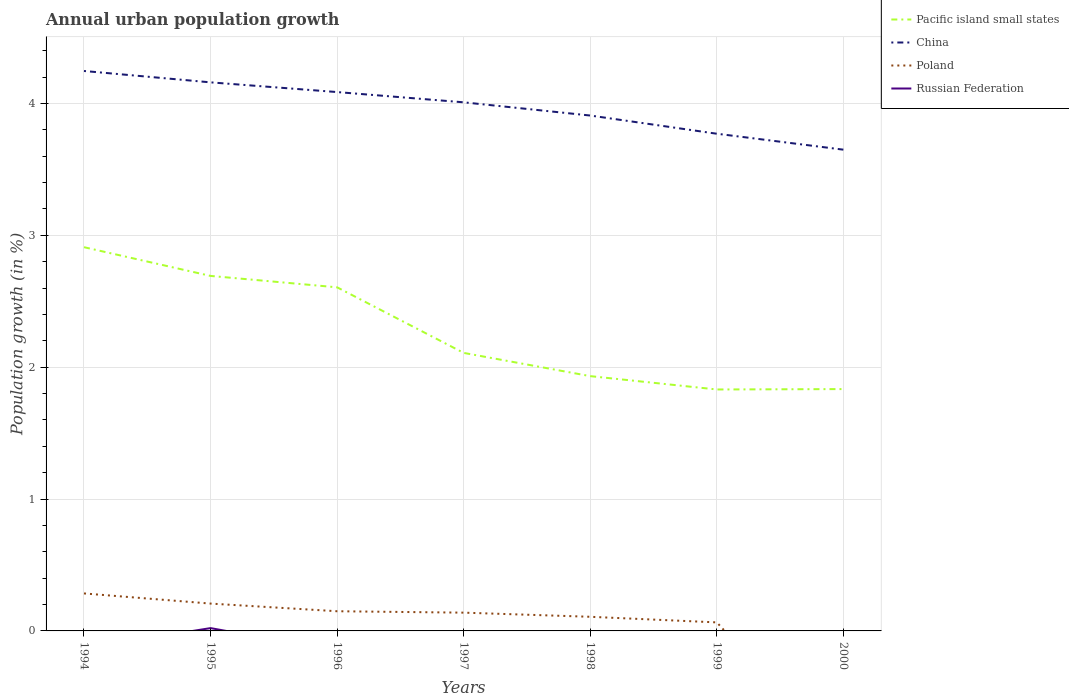How many different coloured lines are there?
Your answer should be very brief. 4. Does the line corresponding to China intersect with the line corresponding to Russian Federation?
Your answer should be compact. No. Across all years, what is the maximum percentage of urban population growth in China?
Provide a succinct answer. 3.65. What is the total percentage of urban population growth in Pacific island small states in the graph?
Offer a terse response. 0.3. What is the difference between the highest and the second highest percentage of urban population growth in China?
Give a very brief answer. 0.6. What is the difference between the highest and the lowest percentage of urban population growth in China?
Your answer should be compact. 4. Is the percentage of urban population growth in Poland strictly greater than the percentage of urban population growth in Pacific island small states over the years?
Ensure brevity in your answer.  Yes. How many lines are there?
Give a very brief answer. 4. Are the values on the major ticks of Y-axis written in scientific E-notation?
Ensure brevity in your answer.  No. Does the graph contain any zero values?
Offer a very short reply. Yes. Does the graph contain grids?
Offer a terse response. Yes. How are the legend labels stacked?
Your response must be concise. Vertical. What is the title of the graph?
Keep it short and to the point. Annual urban population growth. What is the label or title of the X-axis?
Offer a terse response. Years. What is the label or title of the Y-axis?
Give a very brief answer. Population growth (in %). What is the Population growth (in %) of Pacific island small states in 1994?
Your response must be concise. 2.91. What is the Population growth (in %) in China in 1994?
Ensure brevity in your answer.  4.25. What is the Population growth (in %) in Poland in 1994?
Make the answer very short. 0.28. What is the Population growth (in %) of Russian Federation in 1994?
Offer a terse response. 0. What is the Population growth (in %) of Pacific island small states in 1995?
Ensure brevity in your answer.  2.69. What is the Population growth (in %) in China in 1995?
Provide a short and direct response. 4.16. What is the Population growth (in %) of Poland in 1995?
Give a very brief answer. 0.21. What is the Population growth (in %) in Russian Federation in 1995?
Your response must be concise. 0.02. What is the Population growth (in %) of Pacific island small states in 1996?
Your response must be concise. 2.61. What is the Population growth (in %) in China in 1996?
Your response must be concise. 4.09. What is the Population growth (in %) of Poland in 1996?
Your response must be concise. 0.15. What is the Population growth (in %) in Pacific island small states in 1997?
Give a very brief answer. 2.11. What is the Population growth (in %) of China in 1997?
Ensure brevity in your answer.  4.01. What is the Population growth (in %) of Poland in 1997?
Offer a very short reply. 0.14. What is the Population growth (in %) of Pacific island small states in 1998?
Provide a short and direct response. 1.93. What is the Population growth (in %) of China in 1998?
Provide a succinct answer. 3.91. What is the Population growth (in %) in Poland in 1998?
Make the answer very short. 0.11. What is the Population growth (in %) in Pacific island small states in 1999?
Your response must be concise. 1.83. What is the Population growth (in %) of China in 1999?
Ensure brevity in your answer.  3.77. What is the Population growth (in %) of Poland in 1999?
Give a very brief answer. 0.06. What is the Population growth (in %) in Pacific island small states in 2000?
Your response must be concise. 1.83. What is the Population growth (in %) of China in 2000?
Offer a terse response. 3.65. Across all years, what is the maximum Population growth (in %) in Pacific island small states?
Make the answer very short. 2.91. Across all years, what is the maximum Population growth (in %) of China?
Your answer should be compact. 4.25. Across all years, what is the maximum Population growth (in %) in Poland?
Keep it short and to the point. 0.28. Across all years, what is the maximum Population growth (in %) of Russian Federation?
Keep it short and to the point. 0.02. Across all years, what is the minimum Population growth (in %) of Pacific island small states?
Make the answer very short. 1.83. Across all years, what is the minimum Population growth (in %) of China?
Offer a terse response. 3.65. What is the total Population growth (in %) of Pacific island small states in the graph?
Offer a terse response. 15.91. What is the total Population growth (in %) in China in the graph?
Give a very brief answer. 27.83. What is the total Population growth (in %) in Poland in the graph?
Your answer should be compact. 0.95. What is the total Population growth (in %) in Russian Federation in the graph?
Your answer should be very brief. 0.02. What is the difference between the Population growth (in %) in Pacific island small states in 1994 and that in 1995?
Make the answer very short. 0.22. What is the difference between the Population growth (in %) in China in 1994 and that in 1995?
Give a very brief answer. 0.09. What is the difference between the Population growth (in %) in Poland in 1994 and that in 1995?
Keep it short and to the point. 0.08. What is the difference between the Population growth (in %) of Pacific island small states in 1994 and that in 1996?
Give a very brief answer. 0.3. What is the difference between the Population growth (in %) in China in 1994 and that in 1996?
Your response must be concise. 0.16. What is the difference between the Population growth (in %) in Poland in 1994 and that in 1996?
Provide a short and direct response. 0.14. What is the difference between the Population growth (in %) of Pacific island small states in 1994 and that in 1997?
Offer a terse response. 0.8. What is the difference between the Population growth (in %) in China in 1994 and that in 1997?
Offer a terse response. 0.24. What is the difference between the Population growth (in %) in Poland in 1994 and that in 1997?
Your response must be concise. 0.15. What is the difference between the Population growth (in %) in Pacific island small states in 1994 and that in 1998?
Offer a very short reply. 0.98. What is the difference between the Population growth (in %) in China in 1994 and that in 1998?
Give a very brief answer. 0.34. What is the difference between the Population growth (in %) in Poland in 1994 and that in 1998?
Offer a very short reply. 0.18. What is the difference between the Population growth (in %) in Pacific island small states in 1994 and that in 1999?
Your response must be concise. 1.08. What is the difference between the Population growth (in %) in China in 1994 and that in 1999?
Your response must be concise. 0.48. What is the difference between the Population growth (in %) in Poland in 1994 and that in 1999?
Keep it short and to the point. 0.22. What is the difference between the Population growth (in %) in Pacific island small states in 1994 and that in 2000?
Offer a very short reply. 1.08. What is the difference between the Population growth (in %) in China in 1994 and that in 2000?
Ensure brevity in your answer.  0.6. What is the difference between the Population growth (in %) in Pacific island small states in 1995 and that in 1996?
Provide a short and direct response. 0.09. What is the difference between the Population growth (in %) in China in 1995 and that in 1996?
Your answer should be compact. 0.07. What is the difference between the Population growth (in %) in Poland in 1995 and that in 1996?
Make the answer very short. 0.06. What is the difference between the Population growth (in %) of Pacific island small states in 1995 and that in 1997?
Offer a terse response. 0.58. What is the difference between the Population growth (in %) in China in 1995 and that in 1997?
Provide a short and direct response. 0.15. What is the difference between the Population growth (in %) in Poland in 1995 and that in 1997?
Keep it short and to the point. 0.07. What is the difference between the Population growth (in %) of Pacific island small states in 1995 and that in 1998?
Your response must be concise. 0.76. What is the difference between the Population growth (in %) of China in 1995 and that in 1998?
Give a very brief answer. 0.25. What is the difference between the Population growth (in %) in Poland in 1995 and that in 1998?
Provide a short and direct response. 0.1. What is the difference between the Population growth (in %) in Pacific island small states in 1995 and that in 1999?
Your response must be concise. 0.86. What is the difference between the Population growth (in %) of China in 1995 and that in 1999?
Provide a succinct answer. 0.39. What is the difference between the Population growth (in %) of Poland in 1995 and that in 1999?
Provide a short and direct response. 0.14. What is the difference between the Population growth (in %) in Pacific island small states in 1995 and that in 2000?
Make the answer very short. 0.86. What is the difference between the Population growth (in %) of China in 1995 and that in 2000?
Your answer should be compact. 0.51. What is the difference between the Population growth (in %) in Pacific island small states in 1996 and that in 1997?
Keep it short and to the point. 0.5. What is the difference between the Population growth (in %) in China in 1996 and that in 1997?
Offer a terse response. 0.08. What is the difference between the Population growth (in %) in Poland in 1996 and that in 1997?
Ensure brevity in your answer.  0.01. What is the difference between the Population growth (in %) of Pacific island small states in 1996 and that in 1998?
Provide a succinct answer. 0.67. What is the difference between the Population growth (in %) of China in 1996 and that in 1998?
Keep it short and to the point. 0.18. What is the difference between the Population growth (in %) of Poland in 1996 and that in 1998?
Your answer should be compact. 0.04. What is the difference between the Population growth (in %) in Pacific island small states in 1996 and that in 1999?
Offer a very short reply. 0.77. What is the difference between the Population growth (in %) in China in 1996 and that in 1999?
Your answer should be compact. 0.32. What is the difference between the Population growth (in %) of Poland in 1996 and that in 1999?
Provide a short and direct response. 0.08. What is the difference between the Population growth (in %) in Pacific island small states in 1996 and that in 2000?
Make the answer very short. 0.77. What is the difference between the Population growth (in %) in China in 1996 and that in 2000?
Keep it short and to the point. 0.44. What is the difference between the Population growth (in %) of Pacific island small states in 1997 and that in 1998?
Offer a very short reply. 0.18. What is the difference between the Population growth (in %) in China in 1997 and that in 1998?
Provide a succinct answer. 0.1. What is the difference between the Population growth (in %) of Poland in 1997 and that in 1998?
Your answer should be compact. 0.03. What is the difference between the Population growth (in %) of Pacific island small states in 1997 and that in 1999?
Offer a very short reply. 0.28. What is the difference between the Population growth (in %) in China in 1997 and that in 1999?
Offer a terse response. 0.24. What is the difference between the Population growth (in %) of Poland in 1997 and that in 1999?
Your answer should be compact. 0.07. What is the difference between the Population growth (in %) in Pacific island small states in 1997 and that in 2000?
Your response must be concise. 0.27. What is the difference between the Population growth (in %) of China in 1997 and that in 2000?
Provide a succinct answer. 0.36. What is the difference between the Population growth (in %) in Pacific island small states in 1998 and that in 1999?
Ensure brevity in your answer.  0.1. What is the difference between the Population growth (in %) in China in 1998 and that in 1999?
Your answer should be very brief. 0.14. What is the difference between the Population growth (in %) in Poland in 1998 and that in 1999?
Ensure brevity in your answer.  0.04. What is the difference between the Population growth (in %) in Pacific island small states in 1998 and that in 2000?
Keep it short and to the point. 0.1. What is the difference between the Population growth (in %) in China in 1998 and that in 2000?
Keep it short and to the point. 0.26. What is the difference between the Population growth (in %) in Pacific island small states in 1999 and that in 2000?
Your response must be concise. -0. What is the difference between the Population growth (in %) of China in 1999 and that in 2000?
Provide a succinct answer. 0.12. What is the difference between the Population growth (in %) in Pacific island small states in 1994 and the Population growth (in %) in China in 1995?
Your response must be concise. -1.25. What is the difference between the Population growth (in %) in Pacific island small states in 1994 and the Population growth (in %) in Poland in 1995?
Offer a terse response. 2.7. What is the difference between the Population growth (in %) of Pacific island small states in 1994 and the Population growth (in %) of Russian Federation in 1995?
Offer a terse response. 2.89. What is the difference between the Population growth (in %) in China in 1994 and the Population growth (in %) in Poland in 1995?
Give a very brief answer. 4.04. What is the difference between the Population growth (in %) in China in 1994 and the Population growth (in %) in Russian Federation in 1995?
Your response must be concise. 4.22. What is the difference between the Population growth (in %) of Poland in 1994 and the Population growth (in %) of Russian Federation in 1995?
Your answer should be very brief. 0.26. What is the difference between the Population growth (in %) of Pacific island small states in 1994 and the Population growth (in %) of China in 1996?
Offer a terse response. -1.18. What is the difference between the Population growth (in %) in Pacific island small states in 1994 and the Population growth (in %) in Poland in 1996?
Ensure brevity in your answer.  2.76. What is the difference between the Population growth (in %) in China in 1994 and the Population growth (in %) in Poland in 1996?
Provide a succinct answer. 4.1. What is the difference between the Population growth (in %) of Pacific island small states in 1994 and the Population growth (in %) of China in 1997?
Provide a short and direct response. -1.1. What is the difference between the Population growth (in %) in Pacific island small states in 1994 and the Population growth (in %) in Poland in 1997?
Make the answer very short. 2.77. What is the difference between the Population growth (in %) in China in 1994 and the Population growth (in %) in Poland in 1997?
Provide a succinct answer. 4.11. What is the difference between the Population growth (in %) of Pacific island small states in 1994 and the Population growth (in %) of China in 1998?
Ensure brevity in your answer.  -1. What is the difference between the Population growth (in %) of Pacific island small states in 1994 and the Population growth (in %) of Poland in 1998?
Offer a terse response. 2.8. What is the difference between the Population growth (in %) in China in 1994 and the Population growth (in %) in Poland in 1998?
Ensure brevity in your answer.  4.14. What is the difference between the Population growth (in %) in Pacific island small states in 1994 and the Population growth (in %) in China in 1999?
Offer a very short reply. -0.86. What is the difference between the Population growth (in %) of Pacific island small states in 1994 and the Population growth (in %) of Poland in 1999?
Your answer should be compact. 2.85. What is the difference between the Population growth (in %) in China in 1994 and the Population growth (in %) in Poland in 1999?
Your response must be concise. 4.18. What is the difference between the Population growth (in %) in Pacific island small states in 1994 and the Population growth (in %) in China in 2000?
Provide a short and direct response. -0.74. What is the difference between the Population growth (in %) of Pacific island small states in 1995 and the Population growth (in %) of China in 1996?
Give a very brief answer. -1.39. What is the difference between the Population growth (in %) in Pacific island small states in 1995 and the Population growth (in %) in Poland in 1996?
Keep it short and to the point. 2.54. What is the difference between the Population growth (in %) of China in 1995 and the Population growth (in %) of Poland in 1996?
Provide a short and direct response. 4.01. What is the difference between the Population growth (in %) of Pacific island small states in 1995 and the Population growth (in %) of China in 1997?
Make the answer very short. -1.32. What is the difference between the Population growth (in %) of Pacific island small states in 1995 and the Population growth (in %) of Poland in 1997?
Offer a terse response. 2.55. What is the difference between the Population growth (in %) in China in 1995 and the Population growth (in %) in Poland in 1997?
Make the answer very short. 4.02. What is the difference between the Population growth (in %) in Pacific island small states in 1995 and the Population growth (in %) in China in 1998?
Keep it short and to the point. -1.22. What is the difference between the Population growth (in %) in Pacific island small states in 1995 and the Population growth (in %) in Poland in 1998?
Provide a short and direct response. 2.58. What is the difference between the Population growth (in %) of China in 1995 and the Population growth (in %) of Poland in 1998?
Provide a short and direct response. 4.05. What is the difference between the Population growth (in %) in Pacific island small states in 1995 and the Population growth (in %) in China in 1999?
Make the answer very short. -1.08. What is the difference between the Population growth (in %) of Pacific island small states in 1995 and the Population growth (in %) of Poland in 1999?
Provide a short and direct response. 2.63. What is the difference between the Population growth (in %) in China in 1995 and the Population growth (in %) in Poland in 1999?
Provide a short and direct response. 4.09. What is the difference between the Population growth (in %) of Pacific island small states in 1995 and the Population growth (in %) of China in 2000?
Ensure brevity in your answer.  -0.96. What is the difference between the Population growth (in %) of Pacific island small states in 1996 and the Population growth (in %) of China in 1997?
Your response must be concise. -1.4. What is the difference between the Population growth (in %) of Pacific island small states in 1996 and the Population growth (in %) of Poland in 1997?
Provide a succinct answer. 2.47. What is the difference between the Population growth (in %) in China in 1996 and the Population growth (in %) in Poland in 1997?
Provide a succinct answer. 3.95. What is the difference between the Population growth (in %) of Pacific island small states in 1996 and the Population growth (in %) of China in 1998?
Provide a succinct answer. -1.3. What is the difference between the Population growth (in %) of Pacific island small states in 1996 and the Population growth (in %) of Poland in 1998?
Your answer should be very brief. 2.5. What is the difference between the Population growth (in %) in China in 1996 and the Population growth (in %) in Poland in 1998?
Your answer should be very brief. 3.98. What is the difference between the Population growth (in %) in Pacific island small states in 1996 and the Population growth (in %) in China in 1999?
Your answer should be very brief. -1.16. What is the difference between the Population growth (in %) in Pacific island small states in 1996 and the Population growth (in %) in Poland in 1999?
Make the answer very short. 2.54. What is the difference between the Population growth (in %) in China in 1996 and the Population growth (in %) in Poland in 1999?
Provide a succinct answer. 4.02. What is the difference between the Population growth (in %) in Pacific island small states in 1996 and the Population growth (in %) in China in 2000?
Keep it short and to the point. -1.04. What is the difference between the Population growth (in %) of Pacific island small states in 1997 and the Population growth (in %) of China in 1998?
Your answer should be compact. -1.8. What is the difference between the Population growth (in %) in Pacific island small states in 1997 and the Population growth (in %) in Poland in 1998?
Your response must be concise. 2. What is the difference between the Population growth (in %) of China in 1997 and the Population growth (in %) of Poland in 1998?
Your answer should be very brief. 3.9. What is the difference between the Population growth (in %) in Pacific island small states in 1997 and the Population growth (in %) in China in 1999?
Offer a terse response. -1.66. What is the difference between the Population growth (in %) in Pacific island small states in 1997 and the Population growth (in %) in Poland in 1999?
Provide a short and direct response. 2.04. What is the difference between the Population growth (in %) of China in 1997 and the Population growth (in %) of Poland in 1999?
Offer a very short reply. 3.94. What is the difference between the Population growth (in %) of Pacific island small states in 1997 and the Population growth (in %) of China in 2000?
Give a very brief answer. -1.54. What is the difference between the Population growth (in %) in Pacific island small states in 1998 and the Population growth (in %) in China in 1999?
Your answer should be very brief. -1.84. What is the difference between the Population growth (in %) in Pacific island small states in 1998 and the Population growth (in %) in Poland in 1999?
Make the answer very short. 1.87. What is the difference between the Population growth (in %) of China in 1998 and the Population growth (in %) of Poland in 1999?
Offer a very short reply. 3.84. What is the difference between the Population growth (in %) in Pacific island small states in 1998 and the Population growth (in %) in China in 2000?
Ensure brevity in your answer.  -1.72. What is the difference between the Population growth (in %) of Pacific island small states in 1999 and the Population growth (in %) of China in 2000?
Offer a very short reply. -1.82. What is the average Population growth (in %) of Pacific island small states per year?
Ensure brevity in your answer.  2.27. What is the average Population growth (in %) in China per year?
Your response must be concise. 3.98. What is the average Population growth (in %) of Poland per year?
Make the answer very short. 0.14. What is the average Population growth (in %) of Russian Federation per year?
Give a very brief answer. 0. In the year 1994, what is the difference between the Population growth (in %) in Pacific island small states and Population growth (in %) in China?
Keep it short and to the point. -1.34. In the year 1994, what is the difference between the Population growth (in %) in Pacific island small states and Population growth (in %) in Poland?
Your response must be concise. 2.63. In the year 1994, what is the difference between the Population growth (in %) in China and Population growth (in %) in Poland?
Your response must be concise. 3.96. In the year 1995, what is the difference between the Population growth (in %) in Pacific island small states and Population growth (in %) in China?
Your response must be concise. -1.47. In the year 1995, what is the difference between the Population growth (in %) in Pacific island small states and Population growth (in %) in Poland?
Your answer should be compact. 2.48. In the year 1995, what is the difference between the Population growth (in %) of Pacific island small states and Population growth (in %) of Russian Federation?
Make the answer very short. 2.67. In the year 1995, what is the difference between the Population growth (in %) of China and Population growth (in %) of Poland?
Make the answer very short. 3.95. In the year 1995, what is the difference between the Population growth (in %) in China and Population growth (in %) in Russian Federation?
Your response must be concise. 4.14. In the year 1995, what is the difference between the Population growth (in %) of Poland and Population growth (in %) of Russian Federation?
Your answer should be very brief. 0.19. In the year 1996, what is the difference between the Population growth (in %) of Pacific island small states and Population growth (in %) of China?
Your response must be concise. -1.48. In the year 1996, what is the difference between the Population growth (in %) of Pacific island small states and Population growth (in %) of Poland?
Your response must be concise. 2.46. In the year 1996, what is the difference between the Population growth (in %) of China and Population growth (in %) of Poland?
Offer a very short reply. 3.94. In the year 1997, what is the difference between the Population growth (in %) in Pacific island small states and Population growth (in %) in China?
Make the answer very short. -1.9. In the year 1997, what is the difference between the Population growth (in %) in Pacific island small states and Population growth (in %) in Poland?
Your answer should be compact. 1.97. In the year 1997, what is the difference between the Population growth (in %) in China and Population growth (in %) in Poland?
Provide a short and direct response. 3.87. In the year 1998, what is the difference between the Population growth (in %) of Pacific island small states and Population growth (in %) of China?
Your answer should be compact. -1.98. In the year 1998, what is the difference between the Population growth (in %) of Pacific island small states and Population growth (in %) of Poland?
Offer a very short reply. 1.82. In the year 1998, what is the difference between the Population growth (in %) in China and Population growth (in %) in Poland?
Offer a very short reply. 3.8. In the year 1999, what is the difference between the Population growth (in %) of Pacific island small states and Population growth (in %) of China?
Your response must be concise. -1.94. In the year 1999, what is the difference between the Population growth (in %) of Pacific island small states and Population growth (in %) of Poland?
Provide a succinct answer. 1.77. In the year 1999, what is the difference between the Population growth (in %) in China and Population growth (in %) in Poland?
Provide a succinct answer. 3.71. In the year 2000, what is the difference between the Population growth (in %) of Pacific island small states and Population growth (in %) of China?
Offer a terse response. -1.82. What is the ratio of the Population growth (in %) in Pacific island small states in 1994 to that in 1995?
Provide a succinct answer. 1.08. What is the ratio of the Population growth (in %) in China in 1994 to that in 1995?
Keep it short and to the point. 1.02. What is the ratio of the Population growth (in %) of Poland in 1994 to that in 1995?
Provide a succinct answer. 1.37. What is the ratio of the Population growth (in %) of Pacific island small states in 1994 to that in 1996?
Offer a terse response. 1.12. What is the ratio of the Population growth (in %) of China in 1994 to that in 1996?
Your response must be concise. 1.04. What is the ratio of the Population growth (in %) of Poland in 1994 to that in 1996?
Provide a short and direct response. 1.9. What is the ratio of the Population growth (in %) of Pacific island small states in 1994 to that in 1997?
Provide a succinct answer. 1.38. What is the ratio of the Population growth (in %) of China in 1994 to that in 1997?
Make the answer very short. 1.06. What is the ratio of the Population growth (in %) in Poland in 1994 to that in 1997?
Make the answer very short. 2.05. What is the ratio of the Population growth (in %) in Pacific island small states in 1994 to that in 1998?
Your response must be concise. 1.51. What is the ratio of the Population growth (in %) in China in 1994 to that in 1998?
Give a very brief answer. 1.09. What is the ratio of the Population growth (in %) in Poland in 1994 to that in 1998?
Keep it short and to the point. 2.65. What is the ratio of the Population growth (in %) in Pacific island small states in 1994 to that in 1999?
Give a very brief answer. 1.59. What is the ratio of the Population growth (in %) in China in 1994 to that in 1999?
Keep it short and to the point. 1.13. What is the ratio of the Population growth (in %) in Poland in 1994 to that in 1999?
Provide a succinct answer. 4.39. What is the ratio of the Population growth (in %) of Pacific island small states in 1994 to that in 2000?
Keep it short and to the point. 1.59. What is the ratio of the Population growth (in %) in China in 1994 to that in 2000?
Offer a terse response. 1.16. What is the ratio of the Population growth (in %) in Pacific island small states in 1995 to that in 1996?
Offer a very short reply. 1.03. What is the ratio of the Population growth (in %) in China in 1995 to that in 1996?
Keep it short and to the point. 1.02. What is the ratio of the Population growth (in %) in Poland in 1995 to that in 1996?
Make the answer very short. 1.39. What is the ratio of the Population growth (in %) in Pacific island small states in 1995 to that in 1997?
Your answer should be very brief. 1.28. What is the ratio of the Population growth (in %) in China in 1995 to that in 1997?
Provide a succinct answer. 1.04. What is the ratio of the Population growth (in %) in Poland in 1995 to that in 1997?
Your response must be concise. 1.5. What is the ratio of the Population growth (in %) in Pacific island small states in 1995 to that in 1998?
Keep it short and to the point. 1.39. What is the ratio of the Population growth (in %) of China in 1995 to that in 1998?
Offer a very short reply. 1.06. What is the ratio of the Population growth (in %) in Poland in 1995 to that in 1998?
Keep it short and to the point. 1.93. What is the ratio of the Population growth (in %) of Pacific island small states in 1995 to that in 1999?
Ensure brevity in your answer.  1.47. What is the ratio of the Population growth (in %) in China in 1995 to that in 1999?
Give a very brief answer. 1.1. What is the ratio of the Population growth (in %) of Poland in 1995 to that in 1999?
Your answer should be very brief. 3.2. What is the ratio of the Population growth (in %) in Pacific island small states in 1995 to that in 2000?
Your answer should be compact. 1.47. What is the ratio of the Population growth (in %) of China in 1995 to that in 2000?
Provide a short and direct response. 1.14. What is the ratio of the Population growth (in %) in Pacific island small states in 1996 to that in 1997?
Ensure brevity in your answer.  1.24. What is the ratio of the Population growth (in %) in China in 1996 to that in 1997?
Make the answer very short. 1.02. What is the ratio of the Population growth (in %) in Poland in 1996 to that in 1997?
Provide a short and direct response. 1.08. What is the ratio of the Population growth (in %) in Pacific island small states in 1996 to that in 1998?
Your response must be concise. 1.35. What is the ratio of the Population growth (in %) of China in 1996 to that in 1998?
Your answer should be very brief. 1.05. What is the ratio of the Population growth (in %) in Poland in 1996 to that in 1998?
Provide a succinct answer. 1.39. What is the ratio of the Population growth (in %) of Pacific island small states in 1996 to that in 1999?
Offer a very short reply. 1.42. What is the ratio of the Population growth (in %) of China in 1996 to that in 1999?
Keep it short and to the point. 1.08. What is the ratio of the Population growth (in %) of Poland in 1996 to that in 1999?
Ensure brevity in your answer.  2.31. What is the ratio of the Population growth (in %) in Pacific island small states in 1996 to that in 2000?
Your answer should be very brief. 1.42. What is the ratio of the Population growth (in %) of China in 1996 to that in 2000?
Offer a very short reply. 1.12. What is the ratio of the Population growth (in %) in Pacific island small states in 1997 to that in 1998?
Offer a terse response. 1.09. What is the ratio of the Population growth (in %) in China in 1997 to that in 1998?
Offer a very short reply. 1.03. What is the ratio of the Population growth (in %) in Poland in 1997 to that in 1998?
Your answer should be compact. 1.29. What is the ratio of the Population growth (in %) in Pacific island small states in 1997 to that in 1999?
Ensure brevity in your answer.  1.15. What is the ratio of the Population growth (in %) in China in 1997 to that in 1999?
Keep it short and to the point. 1.06. What is the ratio of the Population growth (in %) of Poland in 1997 to that in 1999?
Ensure brevity in your answer.  2.14. What is the ratio of the Population growth (in %) in Pacific island small states in 1997 to that in 2000?
Provide a short and direct response. 1.15. What is the ratio of the Population growth (in %) of China in 1997 to that in 2000?
Your answer should be very brief. 1.1. What is the ratio of the Population growth (in %) of Pacific island small states in 1998 to that in 1999?
Offer a terse response. 1.06. What is the ratio of the Population growth (in %) of China in 1998 to that in 1999?
Keep it short and to the point. 1.04. What is the ratio of the Population growth (in %) of Poland in 1998 to that in 1999?
Make the answer very short. 1.66. What is the ratio of the Population growth (in %) in Pacific island small states in 1998 to that in 2000?
Your answer should be very brief. 1.05. What is the ratio of the Population growth (in %) of China in 1998 to that in 2000?
Your response must be concise. 1.07. What is the ratio of the Population growth (in %) in China in 1999 to that in 2000?
Your response must be concise. 1.03. What is the difference between the highest and the second highest Population growth (in %) of Pacific island small states?
Make the answer very short. 0.22. What is the difference between the highest and the second highest Population growth (in %) in China?
Offer a very short reply. 0.09. What is the difference between the highest and the second highest Population growth (in %) of Poland?
Make the answer very short. 0.08. What is the difference between the highest and the lowest Population growth (in %) of Pacific island small states?
Your response must be concise. 1.08. What is the difference between the highest and the lowest Population growth (in %) in China?
Offer a very short reply. 0.6. What is the difference between the highest and the lowest Population growth (in %) of Poland?
Ensure brevity in your answer.  0.28. What is the difference between the highest and the lowest Population growth (in %) of Russian Federation?
Offer a very short reply. 0.02. 